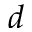<formula> <loc_0><loc_0><loc_500><loc_500>^ { d }</formula> 